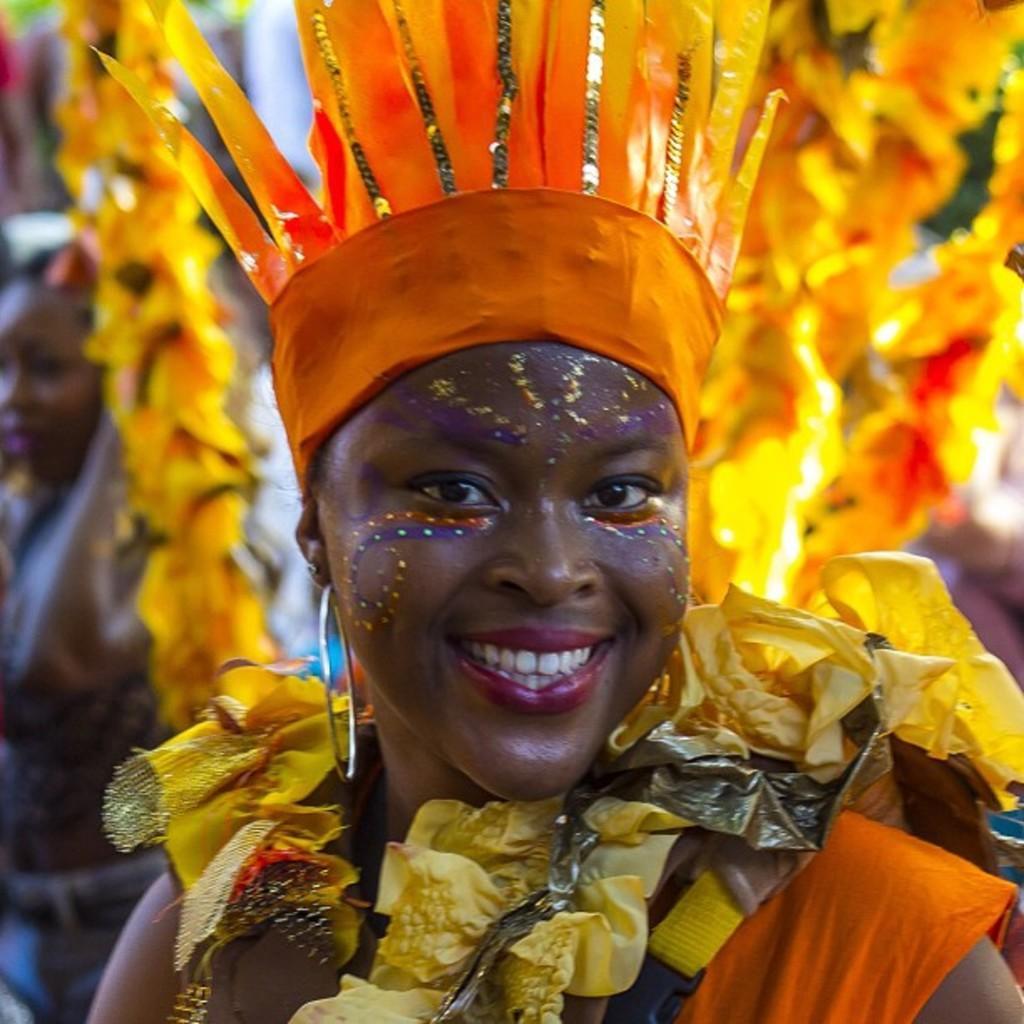Can you describe this image briefly? In this image, we can see a person wearing clothes. In the background, image is blurred. 